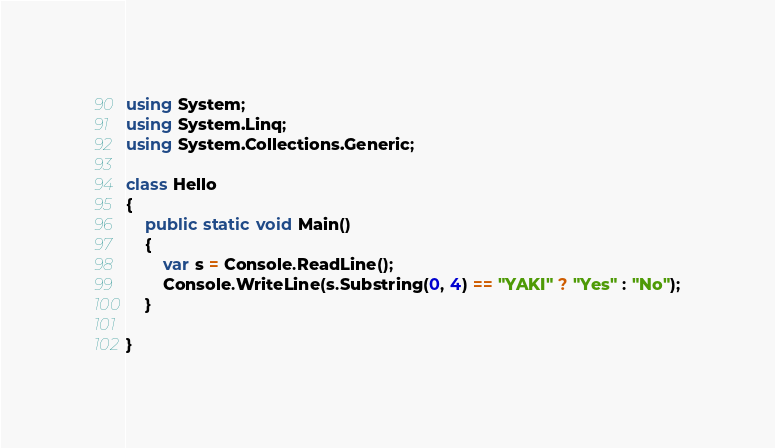Convert code to text. <code><loc_0><loc_0><loc_500><loc_500><_C#_>using System;
using System.Linq;
using System.Collections.Generic;

class Hello
{
    public static void Main()
    {
        var s = Console.ReadLine();
        Console.WriteLine(s.Substring(0, 4) == "YAKI" ? "Yes" : "No");
    }

}
</code> 